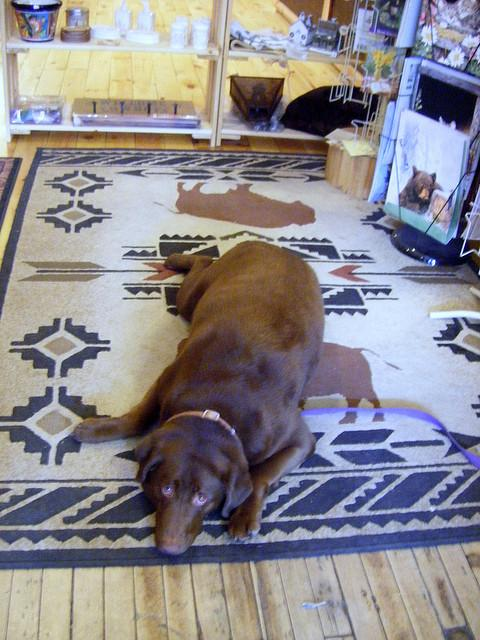What kind of dog is laying on the carpet? chocolate lab 